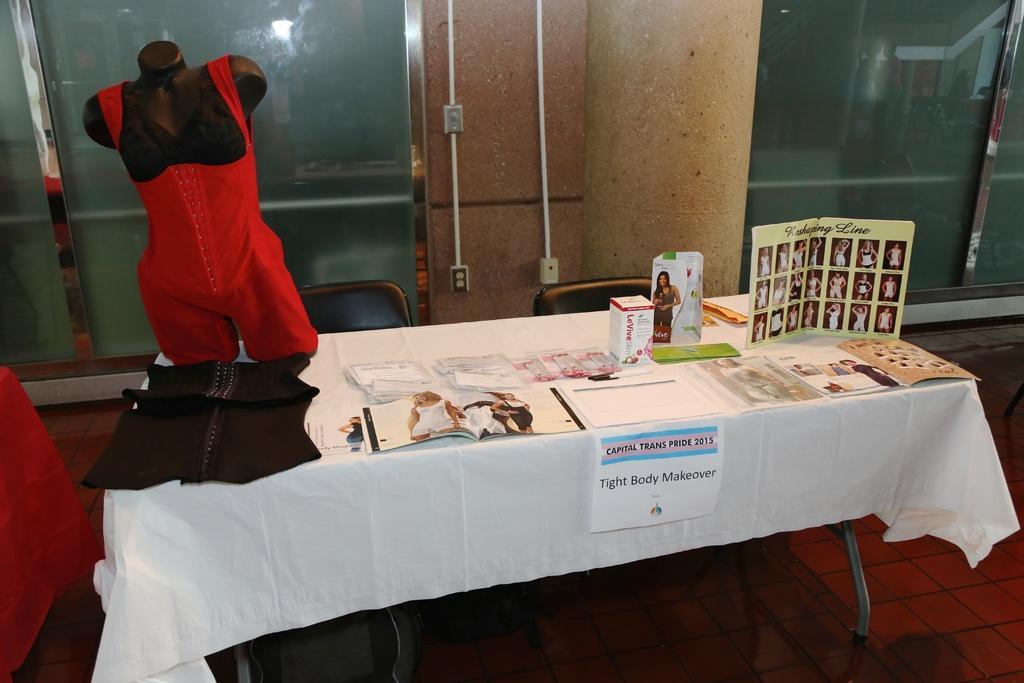In one or two sentences, can you explain what this image depicts? In this image there is a table on which there are boxes, books,clothes and a mannequin. Beside the table there are two chairs. In the background there is a wall to which there are two pipes. On the right side top there is a glass door. 